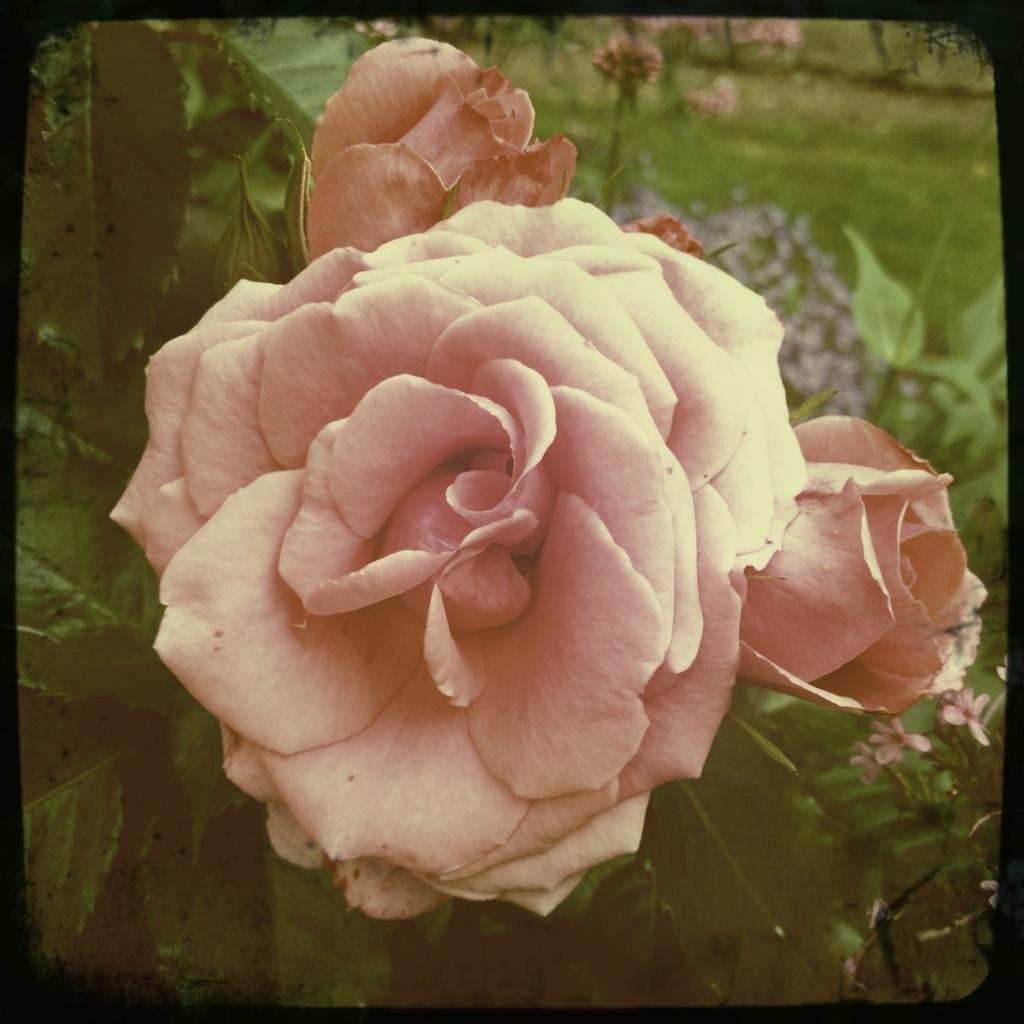What color is the flower in the image? The flower in the image is pink. What else can be seen in the image besides the flower? There are leaves in the image. How many babies are crawling on the flower in the image? There are no babies present in the image; it only features a pink flower and leaves. 